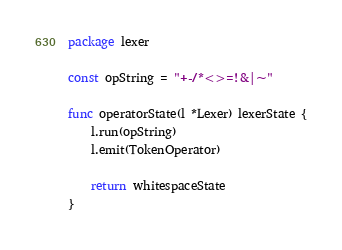Convert code to text. <code><loc_0><loc_0><loc_500><loc_500><_Go_>package lexer

const opString = "+-/*<>=!&|~"

func operatorState(l *Lexer) lexerState {
	l.run(opString)
	l.emit(TokenOperator)

	return whitespaceState
}
</code> 